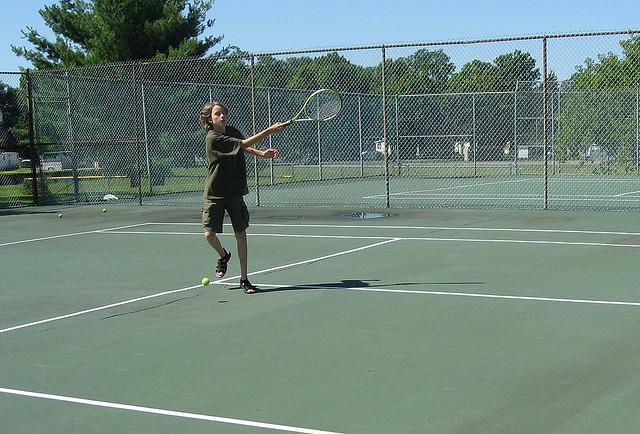What did the boy most likely just do to the ball with his racket?
Choose the right answer from the provided options to respond to the question.
Options: Returned it, served it, missed it, launched it. Missed it. 